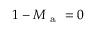Convert formula to latex. <formula><loc_0><loc_0><loc_500><loc_500>1 - M _ { a } = 0</formula> 